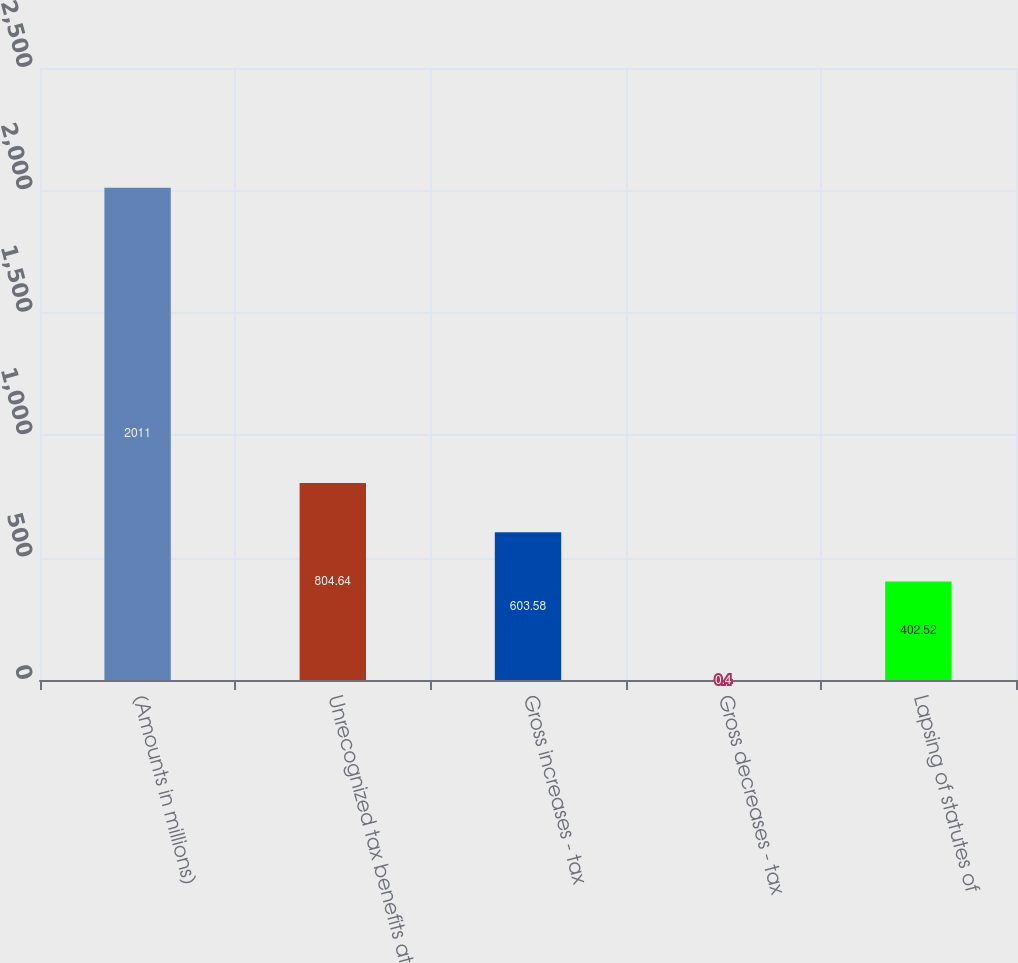Convert chart. <chart><loc_0><loc_0><loc_500><loc_500><bar_chart><fcel>(Amounts in millions)<fcel>Unrecognized tax benefits at<fcel>Gross increases - tax<fcel>Gross decreases - tax<fcel>Lapsing of statutes of<nl><fcel>2011<fcel>804.64<fcel>603.58<fcel>0.4<fcel>402.52<nl></chart> 